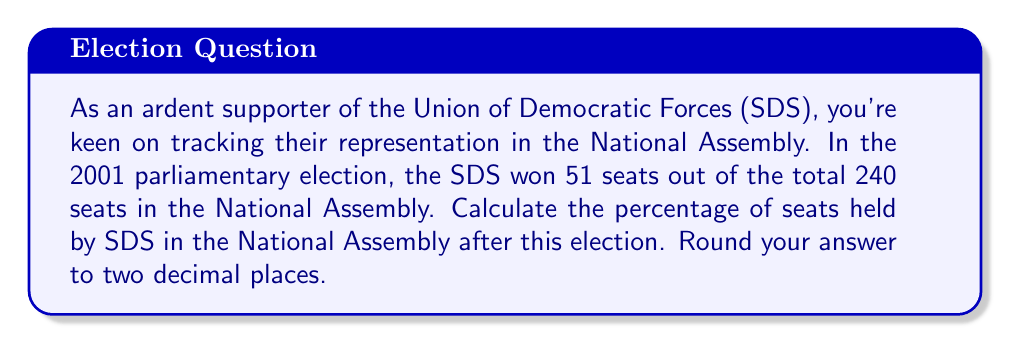Provide a solution to this math problem. To calculate the percentage of seats held by SDS in the National Assembly, we need to use the following formula:

$$ \text{Percentage} = \frac{\text{Number of SDS seats}}{\text{Total number of seats}} \times 100\% $$

Given:
- Number of SDS seats: 51
- Total number of seats in the National Assembly: 240

Let's substitute these values into the formula:

$$ \text{Percentage} = \frac{51}{240} \times 100\% $$

Now, let's perform the calculation:

1. First, divide 51 by 240:
   $\frac{51}{240} = 0.2125$

2. Multiply the result by 100 to get the percentage:
   $0.2125 \times 100 = 21.25\%$

3. Round to two decimal places:
   $21.25\%$ rounds to $21.25\%$

Therefore, the percentage of seats held by SDS in the National Assembly is 21.25%.
Answer: $21.25\%$ 